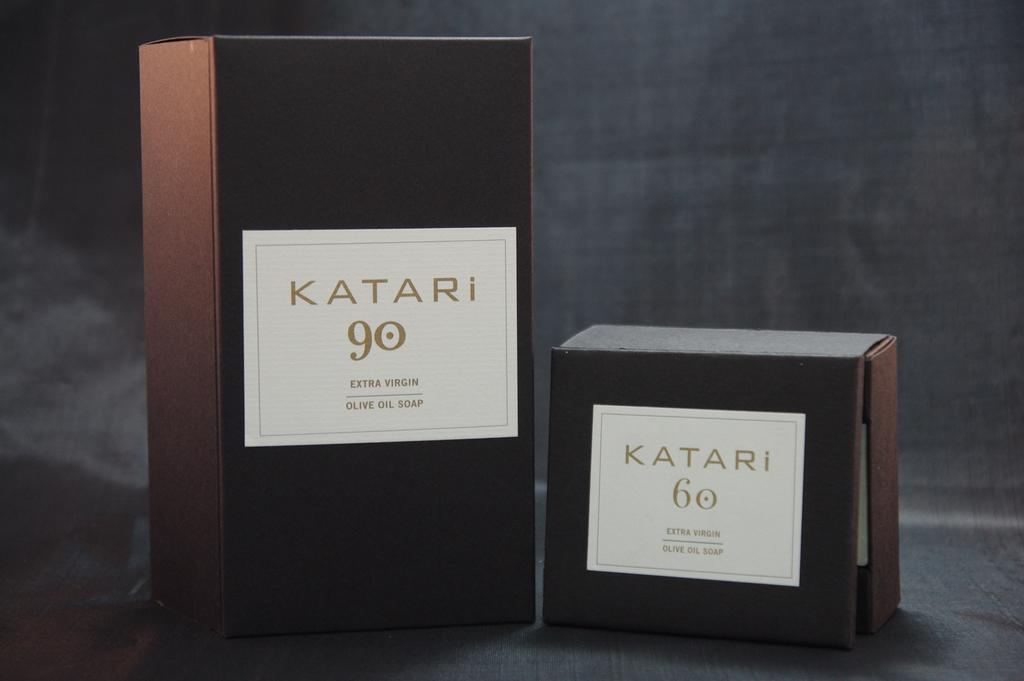What is the brand of the soap?
Your answer should be compact. Katari. What number is on the big box?
Your answer should be very brief. 90. 